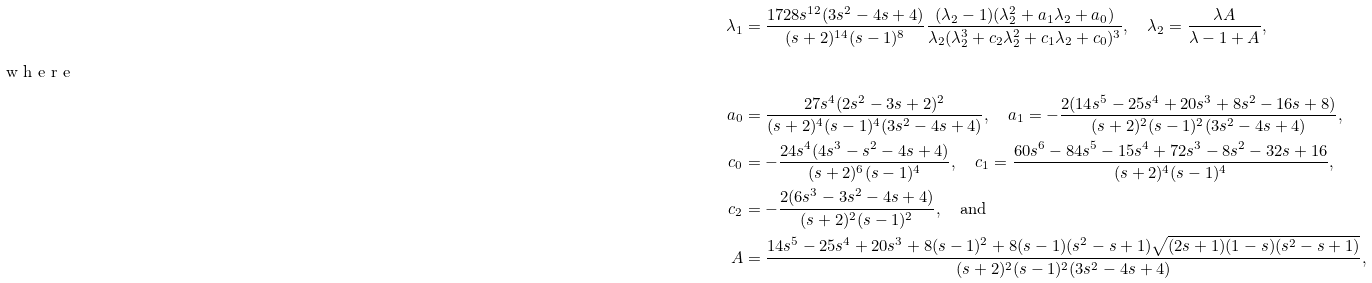<formula> <loc_0><loc_0><loc_500><loc_500>\lambda _ { 1 } & = \frac { 1 7 2 8 s ^ { 1 2 } ( 3 s ^ { 2 } - 4 s + 4 ) } { ( s + 2 ) ^ { 1 4 } ( s - 1 ) ^ { 8 } } \frac { ( \lambda _ { 2 } - 1 ) ( \lambda _ { 2 } ^ { 2 } + a _ { 1 } \lambda _ { 2 } + a _ { 0 } ) } { \lambda _ { 2 } ( \lambda _ { 2 } ^ { 3 } + c _ { 2 } \lambda _ { 2 } ^ { 2 } + c _ { 1 } \lambda _ { 2 } + c _ { 0 } ) ^ { 3 } } , \quad \lambda _ { 2 } = \frac { \lambda A } { \lambda - 1 + A } , \\ \intertext { w h e r e } a _ { 0 } & = \frac { 2 7 s ^ { 4 } ( 2 s ^ { 2 } - 3 s + 2 ) ^ { 2 } } { ( s + 2 ) ^ { 4 } ( s - 1 ) ^ { 4 } ( 3 s ^ { 2 } - 4 s + 4 ) } , \quad a _ { 1 } = - \frac { 2 ( 1 4 s ^ { 5 } - 2 5 s ^ { 4 } + 2 0 s ^ { 3 } + 8 s ^ { 2 } - 1 6 s + 8 ) } { ( s + 2 ) ^ { 2 } ( s - 1 ) ^ { 2 } ( 3 s ^ { 2 } - 4 s + 4 ) } , \\ c _ { 0 } & = - \frac { 2 4 s ^ { 4 } ( 4 s ^ { 3 } - s ^ { 2 } - 4 s + 4 ) } { ( s + 2 ) ^ { 6 } ( s - 1 ) ^ { 4 } } , \quad c _ { 1 } = \frac { 6 0 s ^ { 6 } - 8 4 s ^ { 5 } - 1 5 s ^ { 4 } + 7 2 s ^ { 3 } - 8 s ^ { 2 } - 3 2 s + 1 6 } { ( s + 2 ) ^ { 4 } ( s - 1 ) ^ { 4 } } , \\ c _ { 2 } & = - \frac { 2 ( 6 s ^ { 3 } - 3 s ^ { 2 } - 4 s + 4 ) } { ( s + 2 ) ^ { 2 } ( s - 1 ) ^ { 2 } } , \quad \text {and} \\ A & = \frac { 1 4 s ^ { 5 } - 2 5 s ^ { 4 } + 2 0 s ^ { 3 } + 8 ( s - 1 ) ^ { 2 } + 8 ( s - 1 ) ( s ^ { 2 } - s + 1 ) \sqrt { ( 2 s + 1 ) ( 1 - s ) ( s ^ { 2 } - s + 1 ) } } { ( s + 2 ) ^ { 2 } ( s - 1 ) ^ { 2 } ( 3 s ^ { 2 } - 4 s + 4 ) } ,</formula> 